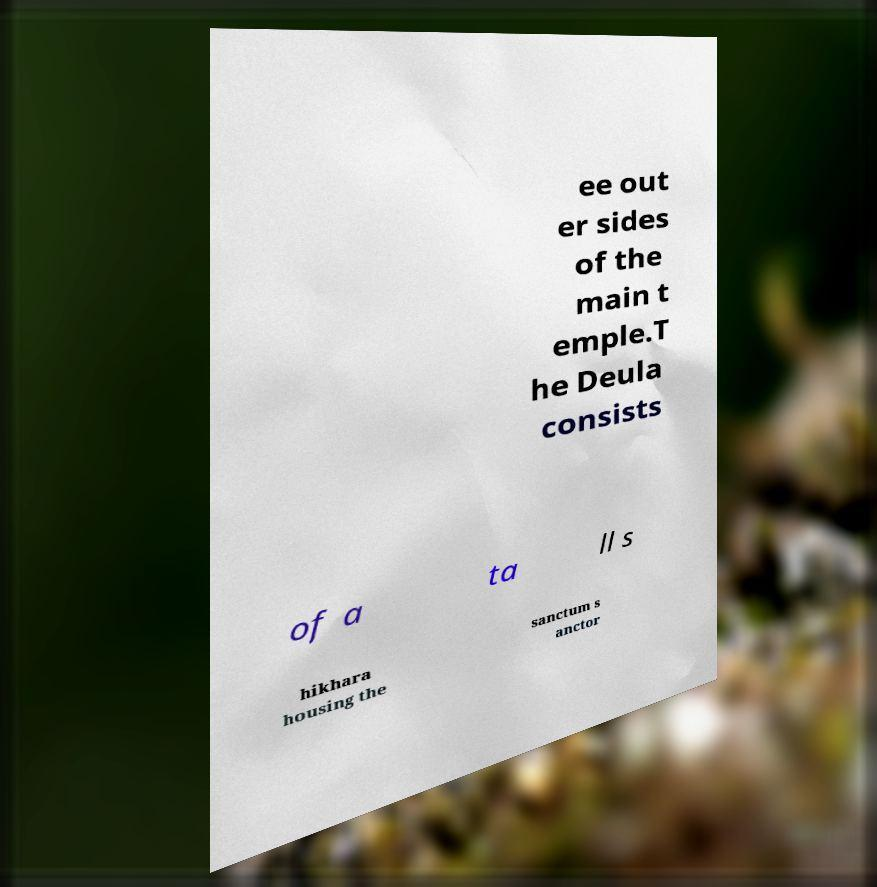Could you assist in decoding the text presented in this image and type it out clearly? ee out er sides of the main t emple.T he Deula consists of a ta ll s hikhara housing the sanctum s anctor 